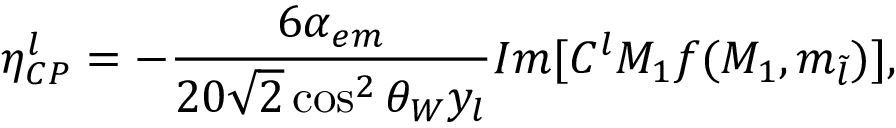<formula> <loc_0><loc_0><loc_500><loc_500>\eta _ { C P } ^ { l } = - \frac { 6 \alpha _ { e m } } { 2 0 \sqrt { 2 } \cos ^ { 2 } { \theta _ { W } } y _ { l } } I m [ C ^ { l } M _ { 1 } f ( M _ { 1 } , m _ { \tilde { l } } ) ] ,</formula> 